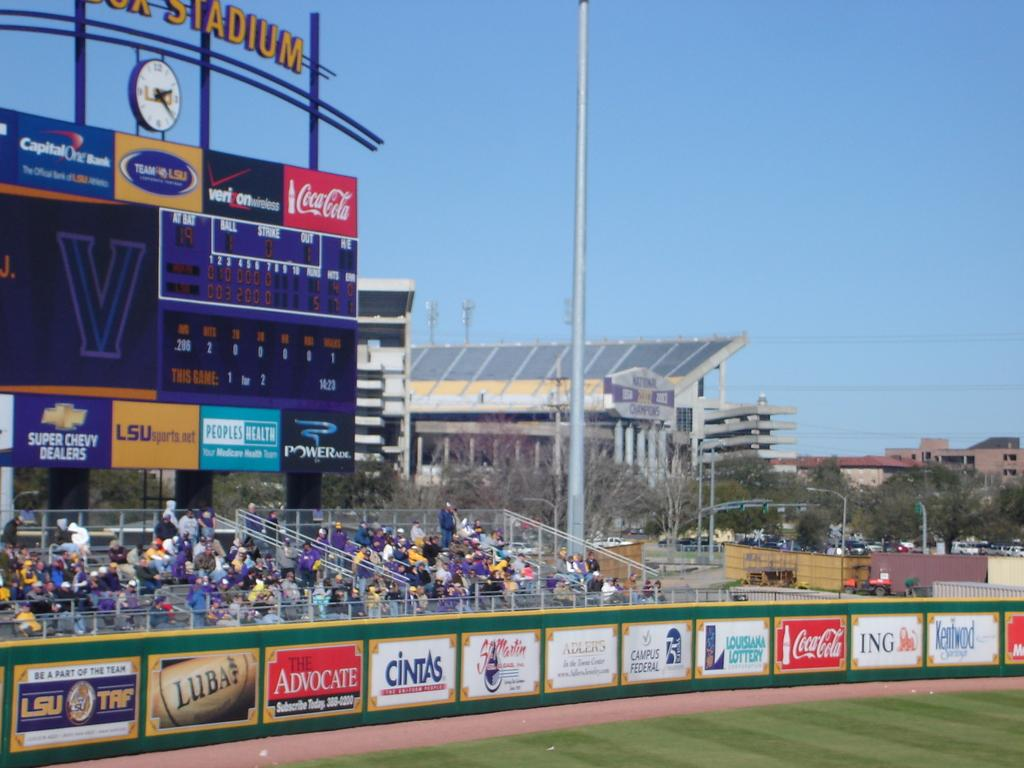<image>
Render a clear and concise summary of the photo. A scoreboard in a baseball stadium rises above a sparse crown who sit in front of many advertising hoardings for Cintas, Coke and many more. 